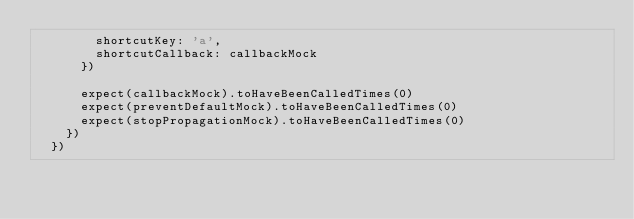Convert code to text. <code><loc_0><loc_0><loc_500><loc_500><_JavaScript_>        shortcutKey: 'a',
        shortcutCallback: callbackMock
      })

      expect(callbackMock).toHaveBeenCalledTimes(0)
      expect(preventDefaultMock).toHaveBeenCalledTimes(0)
      expect(stopPropagationMock).toHaveBeenCalledTimes(0)
    })
  })
</code> 